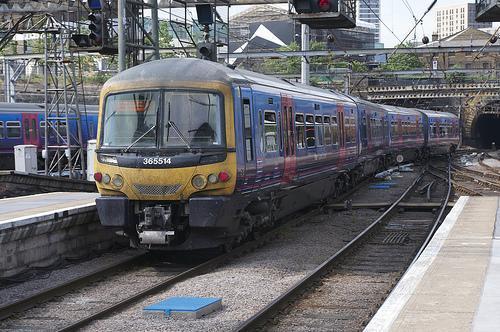How many trains can be seen?
Give a very brief answer. 2. How many passenger cars are pulled by the engine?
Give a very brief answer. 3. How many trains are visible?
Give a very brief answer. 2. 